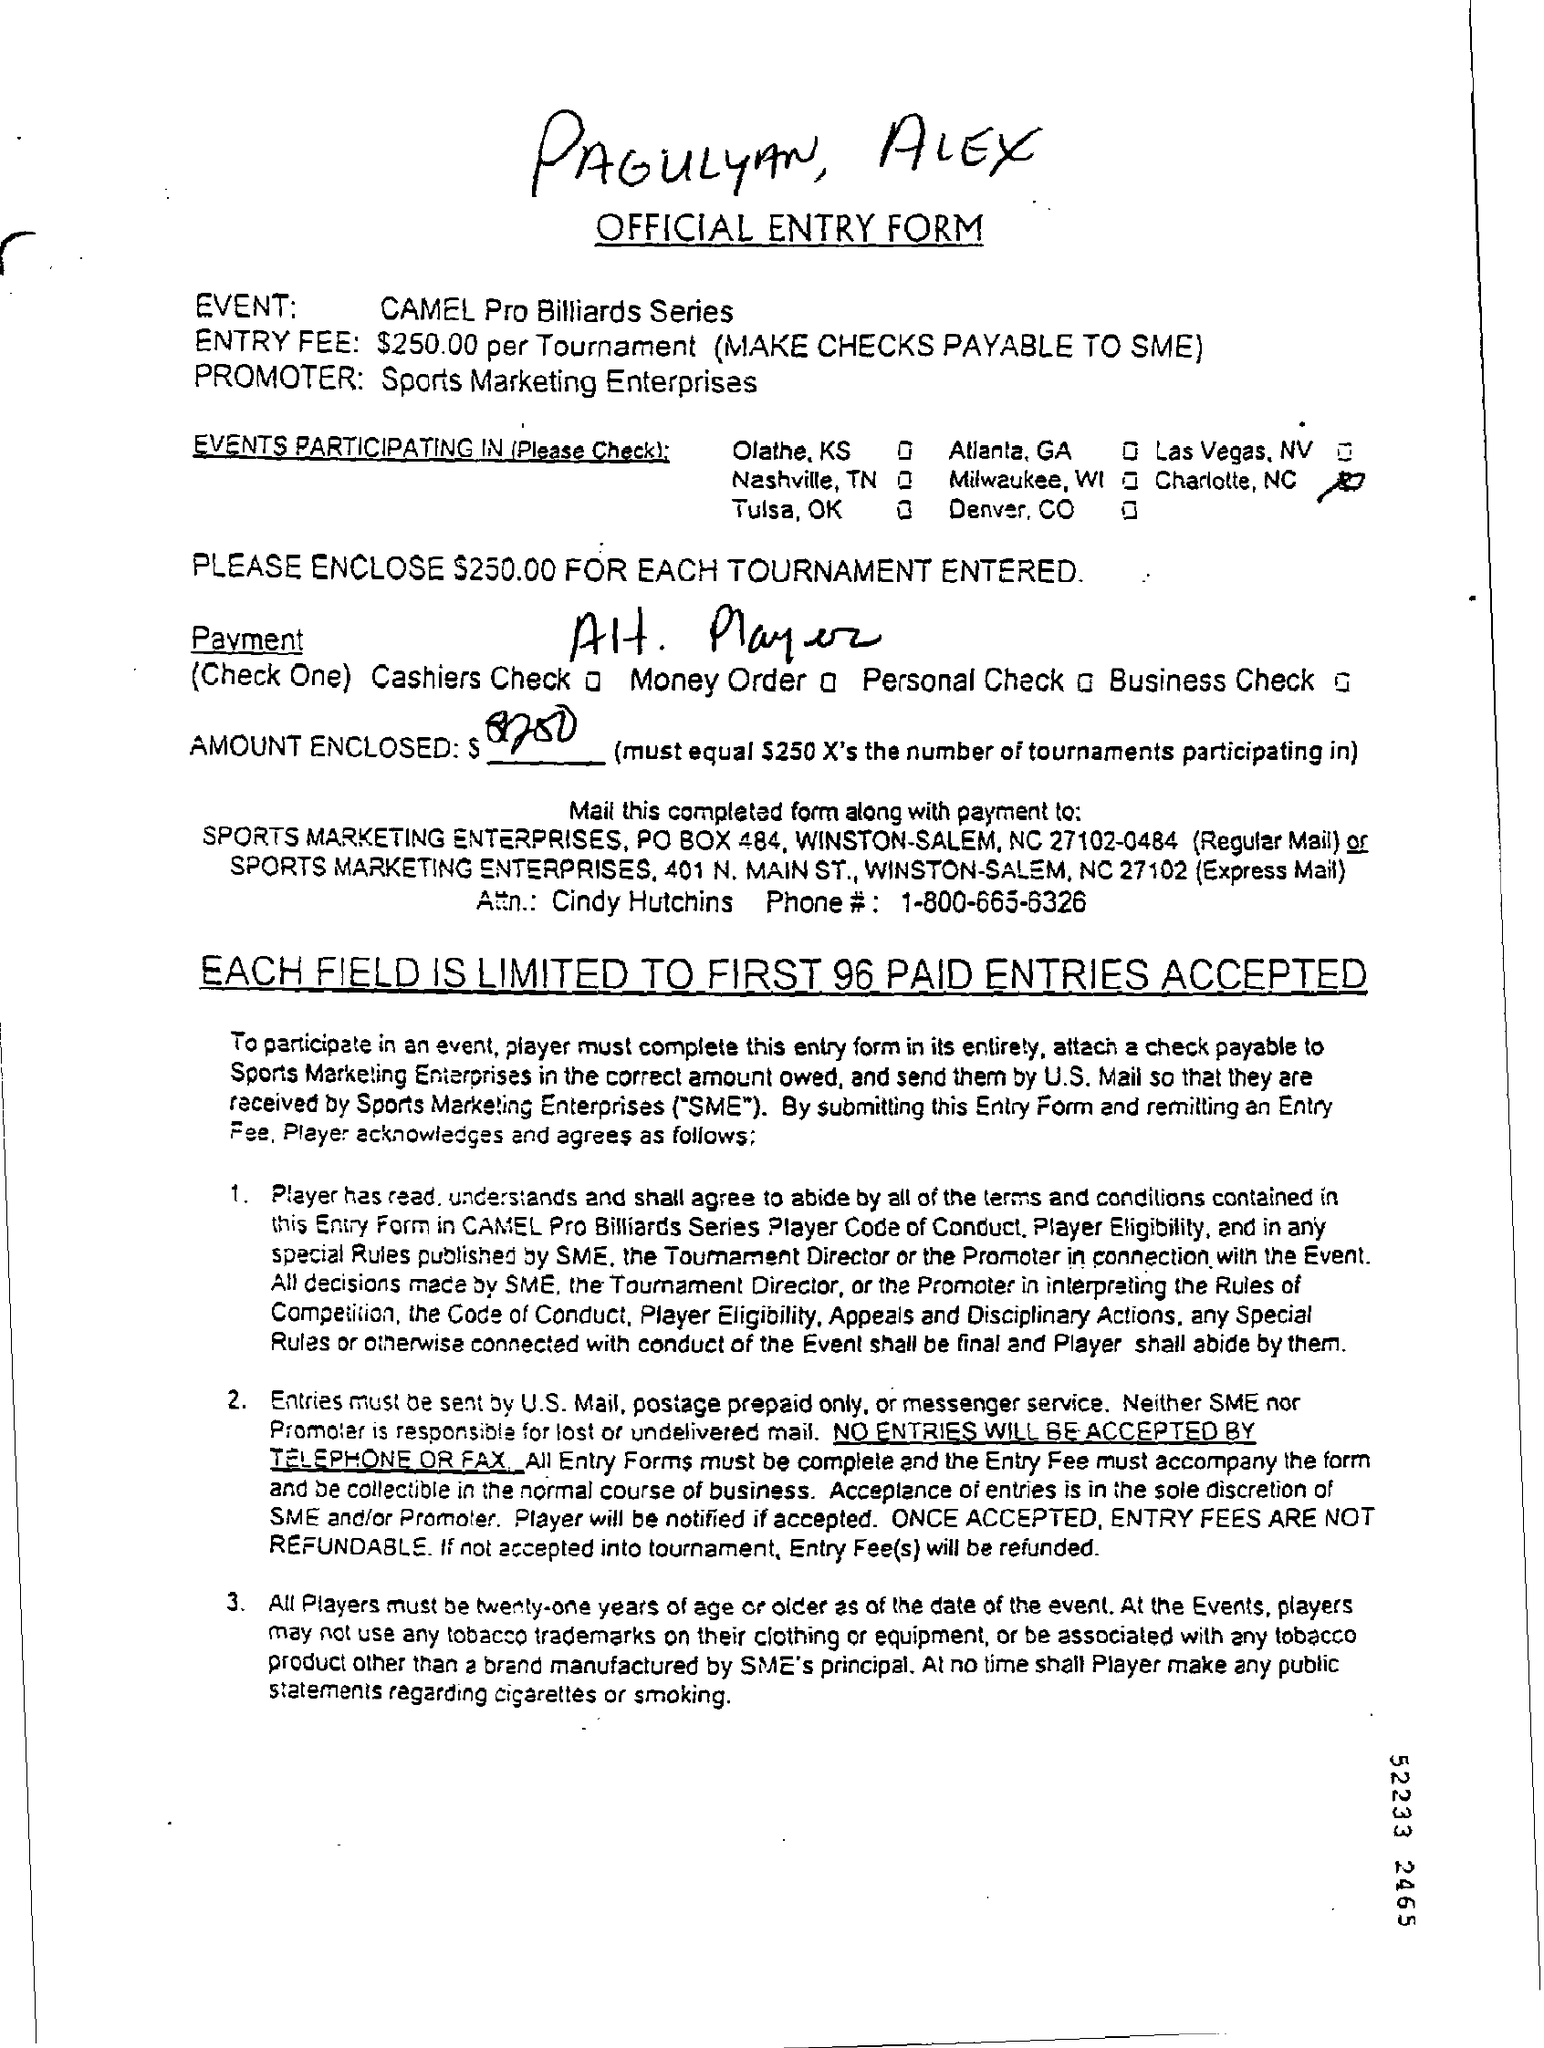Whose names are handwritten at the top?
Give a very brief answer. PAGULYAN, ALEX. What is the event?
Offer a terse response. CAMEL Pro Billiards Series. Who is the promoter?
Offer a terse response. Sports Marketing Enterprises. What is the entry fee?
Your response must be concise. $250.00 per Tournament. How old must all players be?
Your answer should be very brief. Twenty-one years of age or older. 